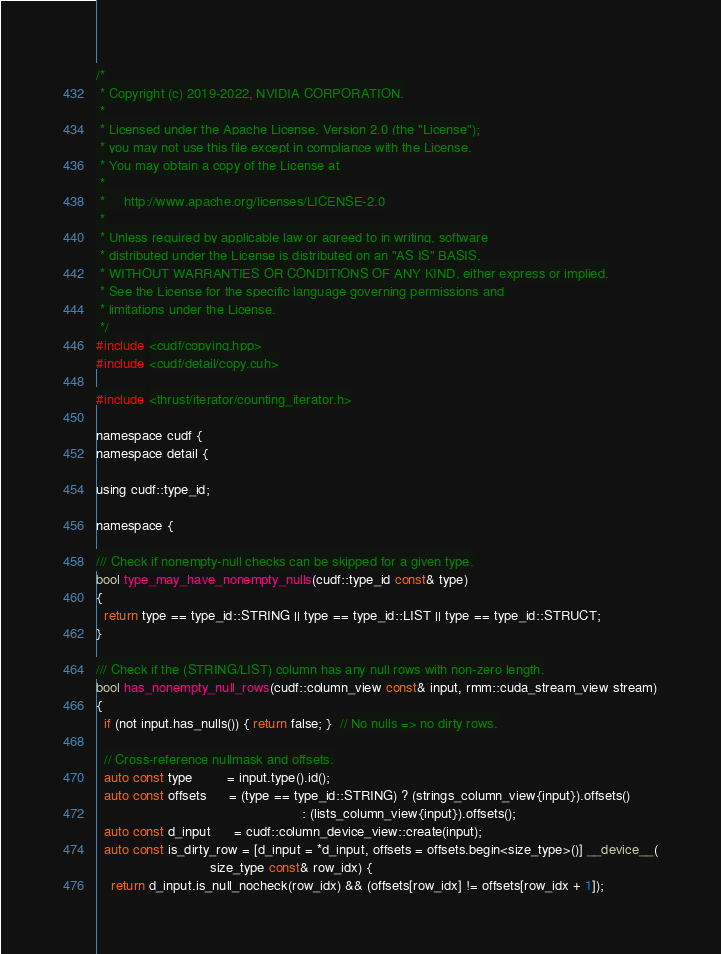<code> <loc_0><loc_0><loc_500><loc_500><_Cuda_>/*
 * Copyright (c) 2019-2022, NVIDIA CORPORATION.
 *
 * Licensed under the Apache License, Version 2.0 (the "License");
 * you may not use this file except in compliance with the License.
 * You may obtain a copy of the License at
 *
 *     http://www.apache.org/licenses/LICENSE-2.0
 *
 * Unless required by applicable law or agreed to in writing, software
 * distributed under the License is distributed on an "AS IS" BASIS,
 * WITHOUT WARRANTIES OR CONDITIONS OF ANY KIND, either express or implied.
 * See the License for the specific language governing permissions and
 * limitations under the License.
 */
#include <cudf/copying.hpp>
#include <cudf/detail/copy.cuh>

#include <thrust/iterator/counting_iterator.h>

namespace cudf {
namespace detail {

using cudf::type_id;

namespace {

/// Check if nonempty-null checks can be skipped for a given type.
bool type_may_have_nonempty_nulls(cudf::type_id const& type)
{
  return type == type_id::STRING || type == type_id::LIST || type == type_id::STRUCT;
}

/// Check if the (STRING/LIST) column has any null rows with non-zero length.
bool has_nonempty_null_rows(cudf::column_view const& input, rmm::cuda_stream_view stream)
{
  if (not input.has_nulls()) { return false; }  // No nulls => no dirty rows.

  // Cross-reference nullmask and offsets.
  auto const type         = input.type().id();
  auto const offsets      = (type == type_id::STRING) ? (strings_column_view{input}).offsets()
                                                      : (lists_column_view{input}).offsets();
  auto const d_input      = cudf::column_device_view::create(input);
  auto const is_dirty_row = [d_input = *d_input, offsets = offsets.begin<size_type>()] __device__(
                              size_type const& row_idx) {
    return d_input.is_null_nocheck(row_idx) && (offsets[row_idx] != offsets[row_idx + 1]);</code> 